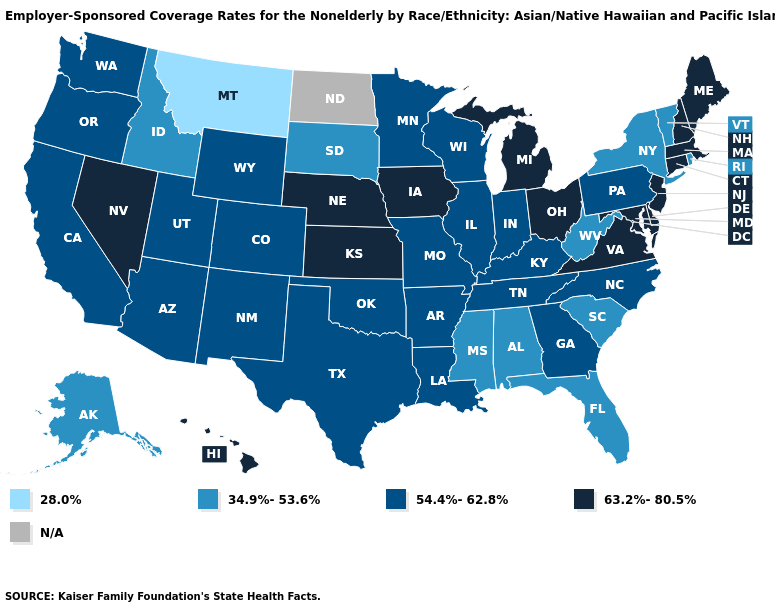Among the states that border Alabama , which have the lowest value?
Write a very short answer. Florida, Mississippi. Does Nevada have the highest value in the West?
Be succinct. Yes. Name the states that have a value in the range 34.9%-53.6%?
Be succinct. Alabama, Alaska, Florida, Idaho, Mississippi, New York, Rhode Island, South Carolina, South Dakota, Vermont, West Virginia. Name the states that have a value in the range 63.2%-80.5%?
Give a very brief answer. Connecticut, Delaware, Hawaii, Iowa, Kansas, Maine, Maryland, Massachusetts, Michigan, Nebraska, Nevada, New Hampshire, New Jersey, Ohio, Virginia. What is the value of Washington?
Write a very short answer. 54.4%-62.8%. What is the value of New Mexico?
Keep it brief. 54.4%-62.8%. Which states hav the highest value in the West?
Short answer required. Hawaii, Nevada. Name the states that have a value in the range 63.2%-80.5%?
Be succinct. Connecticut, Delaware, Hawaii, Iowa, Kansas, Maine, Maryland, Massachusetts, Michigan, Nebraska, Nevada, New Hampshire, New Jersey, Ohio, Virginia. What is the value of Michigan?
Answer briefly. 63.2%-80.5%. What is the lowest value in the USA?
Be succinct. 28.0%. Name the states that have a value in the range 54.4%-62.8%?
Give a very brief answer. Arizona, Arkansas, California, Colorado, Georgia, Illinois, Indiana, Kentucky, Louisiana, Minnesota, Missouri, New Mexico, North Carolina, Oklahoma, Oregon, Pennsylvania, Tennessee, Texas, Utah, Washington, Wisconsin, Wyoming. Which states have the lowest value in the USA?
Give a very brief answer. Montana. Name the states that have a value in the range 54.4%-62.8%?
Be succinct. Arizona, Arkansas, California, Colorado, Georgia, Illinois, Indiana, Kentucky, Louisiana, Minnesota, Missouri, New Mexico, North Carolina, Oklahoma, Oregon, Pennsylvania, Tennessee, Texas, Utah, Washington, Wisconsin, Wyoming. Name the states that have a value in the range 54.4%-62.8%?
Answer briefly. Arizona, Arkansas, California, Colorado, Georgia, Illinois, Indiana, Kentucky, Louisiana, Minnesota, Missouri, New Mexico, North Carolina, Oklahoma, Oregon, Pennsylvania, Tennessee, Texas, Utah, Washington, Wisconsin, Wyoming. 